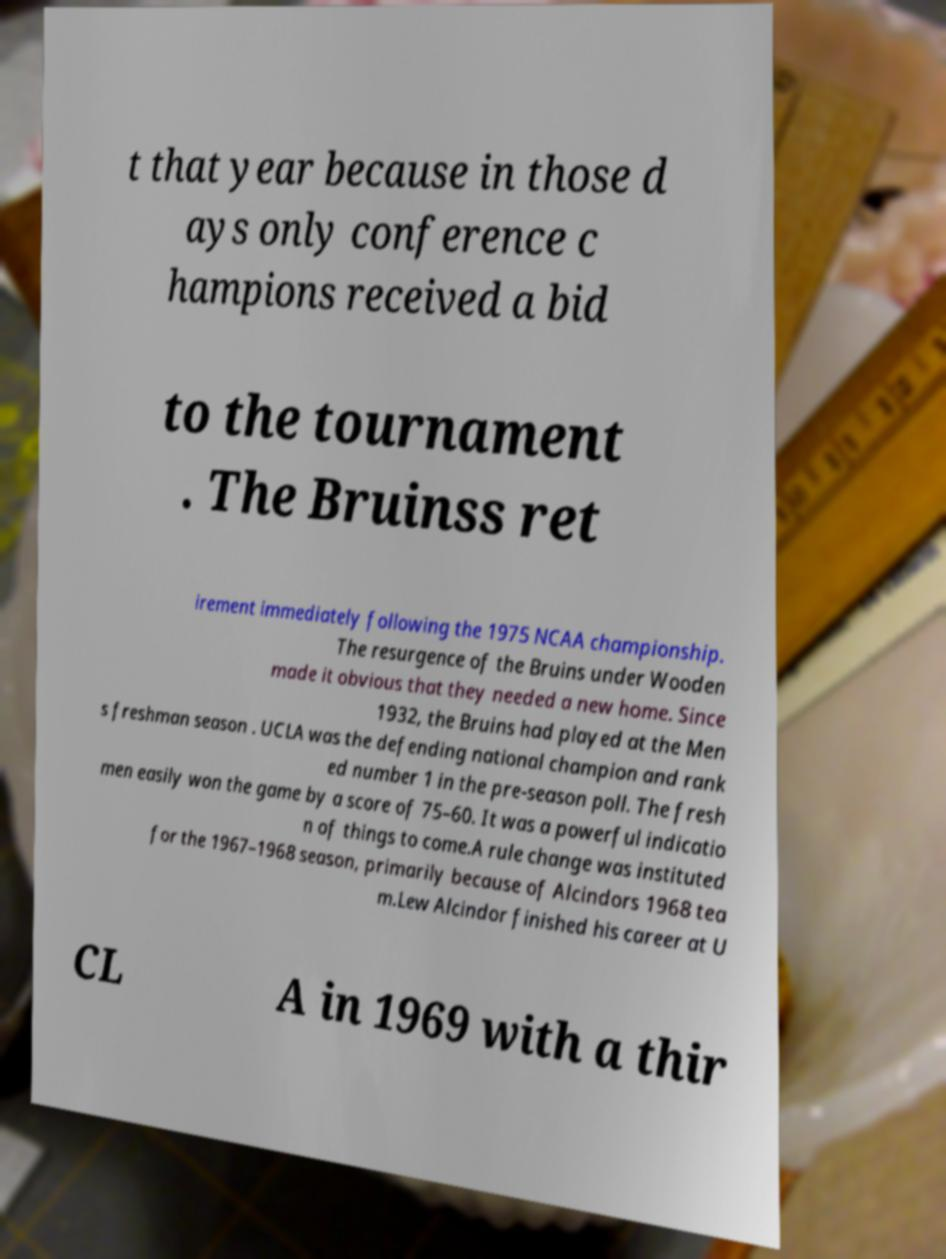There's text embedded in this image that I need extracted. Can you transcribe it verbatim? t that year because in those d ays only conference c hampions received a bid to the tournament . The Bruinss ret irement immediately following the 1975 NCAA championship. The resurgence of the Bruins under Wooden made it obvious that they needed a new home. Since 1932, the Bruins had played at the Men s freshman season . UCLA was the defending national champion and rank ed number 1 in the pre-season poll. The fresh men easily won the game by a score of 75–60. It was a powerful indicatio n of things to come.A rule change was instituted for the 1967–1968 season, primarily because of Alcindors 1968 tea m.Lew Alcindor finished his career at U CL A in 1969 with a thir 